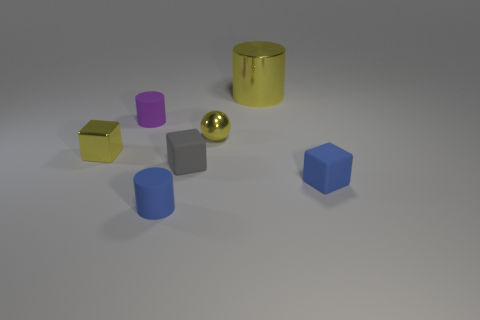There is a tiny object that is the same color as the sphere; what is its shape?
Offer a terse response. Cube. What is the size of the metal block that is the same color as the small ball?
Offer a very short reply. Small. Is the size of the rubber cube that is left of the yellow cylinder the same as the object that is to the right of the large yellow shiny cylinder?
Provide a short and direct response. Yes. What is the size of the object that is behind the small metal ball and left of the blue cylinder?
Offer a very short reply. Small. What color is the other small object that is the same shape as the purple matte object?
Keep it short and to the point. Blue. Is the number of tiny blue cubes that are in front of the blue matte block greater than the number of cylinders that are on the left side of the small shiny ball?
Provide a short and direct response. No. How many other things are there of the same shape as the small gray thing?
Your answer should be compact. 2. Is there a tiny matte object that is right of the small purple object that is behind the tiny gray rubber thing?
Give a very brief answer. Yes. What number of yellow shiny blocks are there?
Your answer should be compact. 1. Is the color of the big thing the same as the tiny matte block to the right of the big yellow metal object?
Keep it short and to the point. No. 